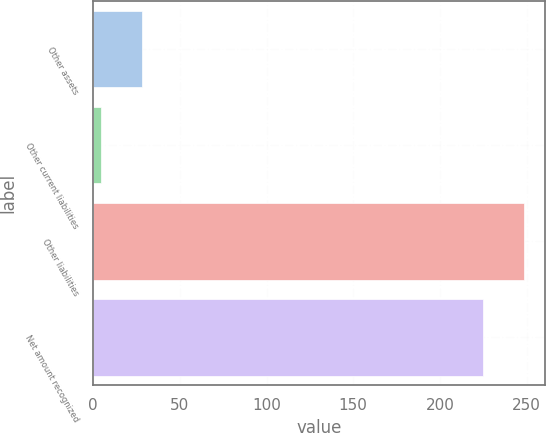Convert chart. <chart><loc_0><loc_0><loc_500><loc_500><bar_chart><fcel>Other assets<fcel>Other current liabilities<fcel>Other liabilities<fcel>Net amount recognized<nl><fcel>28.31<fcel>4.6<fcel>248.31<fcel>224.6<nl></chart> 